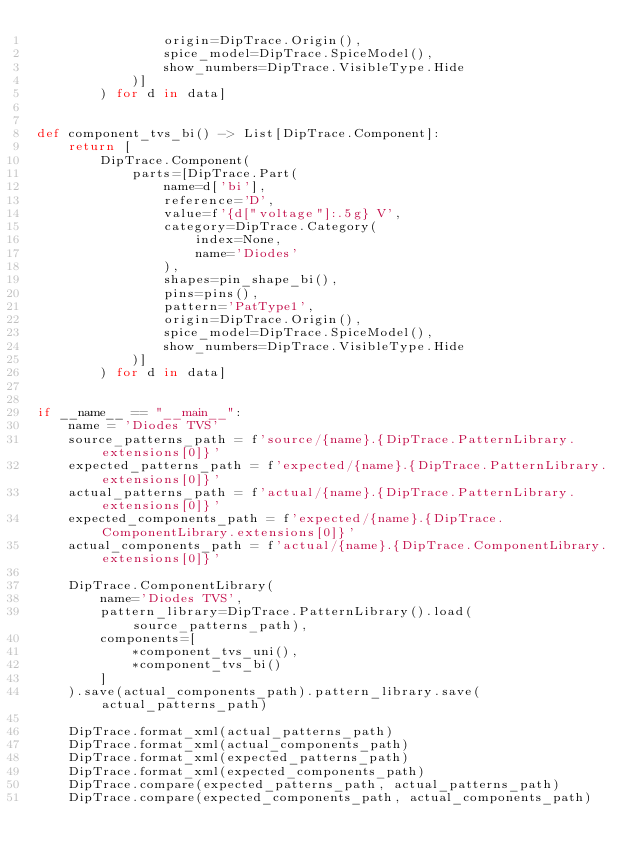Convert code to text. <code><loc_0><loc_0><loc_500><loc_500><_Python_>				origin=DipTrace.Origin(),
				spice_model=DipTrace.SpiceModel(),
				show_numbers=DipTrace.VisibleType.Hide
			)]
		) for d in data]


def component_tvs_bi() -> List[DipTrace.Component]:
	return [
		DipTrace.Component(
			parts=[DipTrace.Part(
				name=d['bi'],
				reference='D',
				value=f'{d["voltage"]:.5g} V',
				category=DipTrace.Category(
					index=None,
					name='Diodes'
				),
				shapes=pin_shape_bi(),
				pins=pins(),
				pattern='PatType1',
				origin=DipTrace.Origin(),
				spice_model=DipTrace.SpiceModel(),
				show_numbers=DipTrace.VisibleType.Hide
			)]
		) for d in data]


if __name__ == "__main__":
	name = 'Diodes TVS'
	source_patterns_path = f'source/{name}.{DipTrace.PatternLibrary.extensions[0]}'
	expected_patterns_path = f'expected/{name}.{DipTrace.PatternLibrary.extensions[0]}'
	actual_patterns_path = f'actual/{name}.{DipTrace.PatternLibrary.extensions[0]}'
	expected_components_path = f'expected/{name}.{DipTrace.ComponentLibrary.extensions[0]}'
	actual_components_path = f'actual/{name}.{DipTrace.ComponentLibrary.extensions[0]}'

	DipTrace.ComponentLibrary(
		name='Diodes TVS',
		pattern_library=DipTrace.PatternLibrary().load(source_patterns_path),
		components=[
			*component_tvs_uni(),
			*component_tvs_bi()
		]
	).save(actual_components_path).pattern_library.save(actual_patterns_path)

	DipTrace.format_xml(actual_patterns_path)
	DipTrace.format_xml(actual_components_path)
	DipTrace.format_xml(expected_patterns_path)
	DipTrace.format_xml(expected_components_path)
	DipTrace.compare(expected_patterns_path, actual_patterns_path)
	DipTrace.compare(expected_components_path, actual_components_path)
</code> 